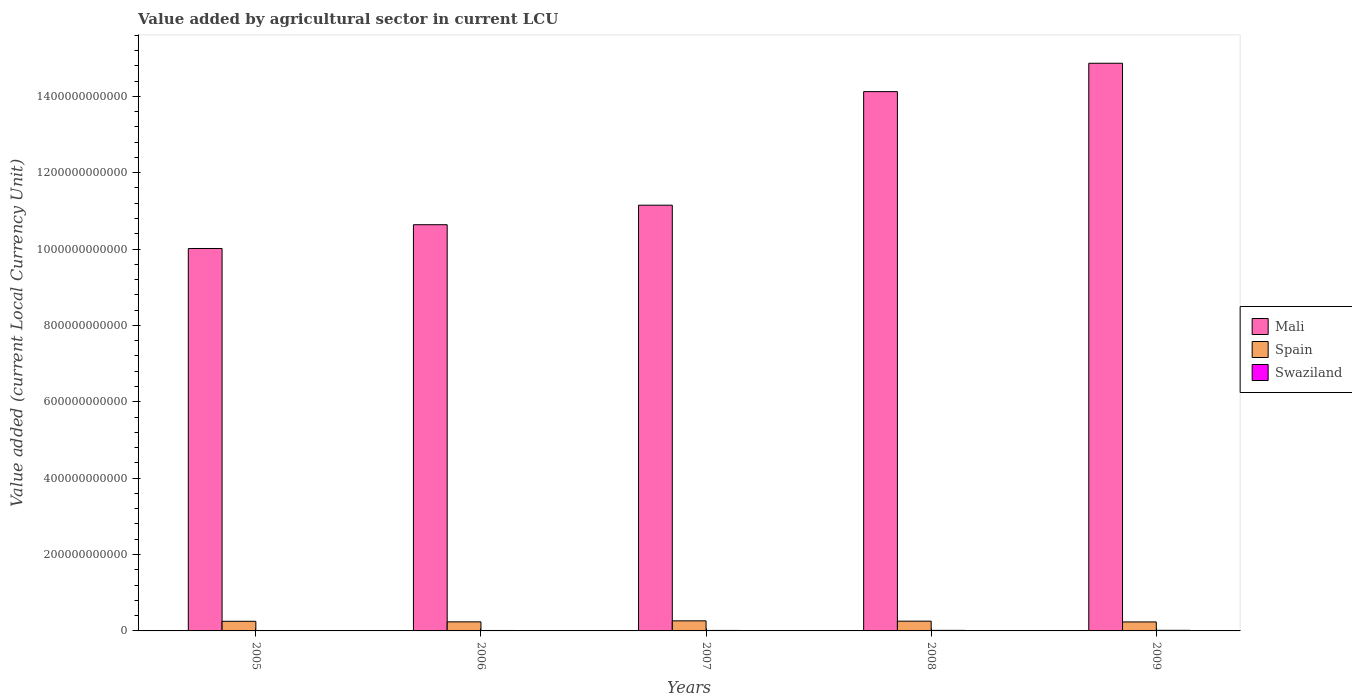Are the number of bars per tick equal to the number of legend labels?
Make the answer very short. Yes. Are the number of bars on each tick of the X-axis equal?
Give a very brief answer. Yes. What is the label of the 3rd group of bars from the left?
Your answer should be very brief. 2007. What is the value added by agricultural sector in Spain in 2006?
Your answer should be very brief. 2.37e+1. Across all years, what is the maximum value added by agricultural sector in Spain?
Your answer should be very brief. 2.64e+1. Across all years, what is the minimum value added by agricultural sector in Spain?
Give a very brief answer. 2.35e+1. In which year was the value added by agricultural sector in Swaziland maximum?
Your response must be concise. 2009. In which year was the value added by agricultural sector in Mali minimum?
Your response must be concise. 2005. What is the total value added by agricultural sector in Swaziland in the graph?
Give a very brief answer. 6.62e+09. What is the difference between the value added by agricultural sector in Swaziland in 2006 and that in 2007?
Your answer should be compact. -1.26e+08. What is the difference between the value added by agricultural sector in Swaziland in 2007 and the value added by agricultural sector in Spain in 2006?
Your answer should be very brief. -2.25e+1. What is the average value added by agricultural sector in Spain per year?
Your response must be concise. 2.49e+1. In the year 2005, what is the difference between the value added by agricultural sector in Mali and value added by agricultural sector in Swaziland?
Ensure brevity in your answer.  1.00e+12. What is the ratio of the value added by agricultural sector in Swaziland in 2006 to that in 2008?
Provide a succinct answer. 0.79. Is the difference between the value added by agricultural sector in Mali in 2005 and 2006 greater than the difference between the value added by agricultural sector in Swaziland in 2005 and 2006?
Make the answer very short. No. What is the difference between the highest and the second highest value added by agricultural sector in Swaziland?
Provide a short and direct response. 1.28e+08. What is the difference between the highest and the lowest value added by agricultural sector in Swaziland?
Ensure brevity in your answer.  4.49e+08. What does the 3rd bar from the left in 2008 represents?
Ensure brevity in your answer.  Swaziland. What does the 1st bar from the right in 2007 represents?
Your response must be concise. Swaziland. Is it the case that in every year, the sum of the value added by agricultural sector in Spain and value added by agricultural sector in Mali is greater than the value added by agricultural sector in Swaziland?
Offer a terse response. Yes. Are all the bars in the graph horizontal?
Ensure brevity in your answer.  No. How many years are there in the graph?
Your answer should be compact. 5. What is the difference between two consecutive major ticks on the Y-axis?
Your answer should be very brief. 2.00e+11. Are the values on the major ticks of Y-axis written in scientific E-notation?
Provide a succinct answer. No. Does the graph contain any zero values?
Provide a short and direct response. No. How many legend labels are there?
Offer a terse response. 3. What is the title of the graph?
Provide a succinct answer. Value added by agricultural sector in current LCU. Does "Serbia" appear as one of the legend labels in the graph?
Give a very brief answer. No. What is the label or title of the Y-axis?
Ensure brevity in your answer.  Value added (current Local Currency Unit). What is the Value added (current Local Currency Unit) in Mali in 2005?
Your answer should be very brief. 1.00e+12. What is the Value added (current Local Currency Unit) in Spain in 2005?
Offer a very short reply. 2.52e+1. What is the Value added (current Local Currency Unit) of Swaziland in 2005?
Your answer should be very brief. 1.14e+09. What is the Value added (current Local Currency Unit) of Mali in 2006?
Your answer should be very brief. 1.06e+12. What is the Value added (current Local Currency Unit) of Spain in 2006?
Offer a very short reply. 2.37e+1. What is the Value added (current Local Currency Unit) in Swaziland in 2006?
Ensure brevity in your answer.  1.15e+09. What is the Value added (current Local Currency Unit) in Mali in 2007?
Provide a short and direct response. 1.11e+12. What is the Value added (current Local Currency Unit) of Spain in 2007?
Ensure brevity in your answer.  2.64e+1. What is the Value added (current Local Currency Unit) in Swaziland in 2007?
Your answer should be very brief. 1.28e+09. What is the Value added (current Local Currency Unit) of Mali in 2008?
Give a very brief answer. 1.41e+12. What is the Value added (current Local Currency Unit) in Spain in 2008?
Offer a very short reply. 2.56e+1. What is the Value added (current Local Currency Unit) of Swaziland in 2008?
Keep it short and to the point. 1.46e+09. What is the Value added (current Local Currency Unit) of Mali in 2009?
Offer a terse response. 1.49e+12. What is the Value added (current Local Currency Unit) of Spain in 2009?
Your answer should be compact. 2.35e+1. What is the Value added (current Local Currency Unit) of Swaziland in 2009?
Make the answer very short. 1.59e+09. Across all years, what is the maximum Value added (current Local Currency Unit) in Mali?
Your answer should be compact. 1.49e+12. Across all years, what is the maximum Value added (current Local Currency Unit) of Spain?
Your answer should be very brief. 2.64e+1. Across all years, what is the maximum Value added (current Local Currency Unit) of Swaziland?
Give a very brief answer. 1.59e+09. Across all years, what is the minimum Value added (current Local Currency Unit) in Mali?
Ensure brevity in your answer.  1.00e+12. Across all years, what is the minimum Value added (current Local Currency Unit) of Spain?
Make the answer very short. 2.35e+1. Across all years, what is the minimum Value added (current Local Currency Unit) of Swaziland?
Give a very brief answer. 1.14e+09. What is the total Value added (current Local Currency Unit) in Mali in the graph?
Provide a short and direct response. 6.08e+12. What is the total Value added (current Local Currency Unit) of Spain in the graph?
Ensure brevity in your answer.  1.24e+11. What is the total Value added (current Local Currency Unit) in Swaziland in the graph?
Offer a terse response. 6.62e+09. What is the difference between the Value added (current Local Currency Unit) of Mali in 2005 and that in 2006?
Provide a succinct answer. -6.22e+1. What is the difference between the Value added (current Local Currency Unit) in Spain in 2005 and that in 2006?
Provide a succinct answer. 1.49e+09. What is the difference between the Value added (current Local Currency Unit) of Swaziland in 2005 and that in 2006?
Make the answer very short. -1.25e+07. What is the difference between the Value added (current Local Currency Unit) in Mali in 2005 and that in 2007?
Your answer should be compact. -1.13e+11. What is the difference between the Value added (current Local Currency Unit) in Spain in 2005 and that in 2007?
Provide a succinct answer. -1.14e+09. What is the difference between the Value added (current Local Currency Unit) in Swaziland in 2005 and that in 2007?
Offer a very short reply. -1.38e+08. What is the difference between the Value added (current Local Currency Unit) in Mali in 2005 and that in 2008?
Provide a succinct answer. -4.11e+11. What is the difference between the Value added (current Local Currency Unit) of Spain in 2005 and that in 2008?
Offer a very short reply. -3.23e+08. What is the difference between the Value added (current Local Currency Unit) of Swaziland in 2005 and that in 2008?
Provide a succinct answer. -3.20e+08. What is the difference between the Value added (current Local Currency Unit) of Mali in 2005 and that in 2009?
Your response must be concise. -4.85e+11. What is the difference between the Value added (current Local Currency Unit) in Spain in 2005 and that in 2009?
Give a very brief answer. 1.69e+09. What is the difference between the Value added (current Local Currency Unit) of Swaziland in 2005 and that in 2009?
Offer a terse response. -4.49e+08. What is the difference between the Value added (current Local Currency Unit) of Mali in 2006 and that in 2007?
Offer a very short reply. -5.11e+1. What is the difference between the Value added (current Local Currency Unit) in Spain in 2006 and that in 2007?
Give a very brief answer. -2.63e+09. What is the difference between the Value added (current Local Currency Unit) of Swaziland in 2006 and that in 2007?
Offer a terse response. -1.26e+08. What is the difference between the Value added (current Local Currency Unit) of Mali in 2006 and that in 2008?
Offer a very short reply. -3.49e+11. What is the difference between the Value added (current Local Currency Unit) of Spain in 2006 and that in 2008?
Offer a terse response. -1.81e+09. What is the difference between the Value added (current Local Currency Unit) in Swaziland in 2006 and that in 2008?
Your answer should be compact. -3.08e+08. What is the difference between the Value added (current Local Currency Unit) in Mali in 2006 and that in 2009?
Offer a very short reply. -4.23e+11. What is the difference between the Value added (current Local Currency Unit) in Spain in 2006 and that in 2009?
Keep it short and to the point. 1.99e+08. What is the difference between the Value added (current Local Currency Unit) of Swaziland in 2006 and that in 2009?
Provide a short and direct response. -4.36e+08. What is the difference between the Value added (current Local Currency Unit) in Mali in 2007 and that in 2008?
Your answer should be compact. -2.97e+11. What is the difference between the Value added (current Local Currency Unit) of Spain in 2007 and that in 2008?
Your response must be concise. 8.15e+08. What is the difference between the Value added (current Local Currency Unit) in Swaziland in 2007 and that in 2008?
Keep it short and to the point. -1.82e+08. What is the difference between the Value added (current Local Currency Unit) of Mali in 2007 and that in 2009?
Offer a terse response. -3.72e+11. What is the difference between the Value added (current Local Currency Unit) of Spain in 2007 and that in 2009?
Your answer should be compact. 2.83e+09. What is the difference between the Value added (current Local Currency Unit) in Swaziland in 2007 and that in 2009?
Provide a short and direct response. -3.10e+08. What is the difference between the Value added (current Local Currency Unit) in Mali in 2008 and that in 2009?
Offer a very short reply. -7.43e+1. What is the difference between the Value added (current Local Currency Unit) in Spain in 2008 and that in 2009?
Ensure brevity in your answer.  2.01e+09. What is the difference between the Value added (current Local Currency Unit) of Swaziland in 2008 and that in 2009?
Make the answer very short. -1.28e+08. What is the difference between the Value added (current Local Currency Unit) in Mali in 2005 and the Value added (current Local Currency Unit) in Spain in 2006?
Give a very brief answer. 9.78e+11. What is the difference between the Value added (current Local Currency Unit) in Mali in 2005 and the Value added (current Local Currency Unit) in Swaziland in 2006?
Your response must be concise. 1.00e+12. What is the difference between the Value added (current Local Currency Unit) of Spain in 2005 and the Value added (current Local Currency Unit) of Swaziland in 2006?
Offer a terse response. 2.41e+1. What is the difference between the Value added (current Local Currency Unit) in Mali in 2005 and the Value added (current Local Currency Unit) in Spain in 2007?
Provide a short and direct response. 9.75e+11. What is the difference between the Value added (current Local Currency Unit) of Mali in 2005 and the Value added (current Local Currency Unit) of Swaziland in 2007?
Provide a succinct answer. 1.00e+12. What is the difference between the Value added (current Local Currency Unit) in Spain in 2005 and the Value added (current Local Currency Unit) in Swaziland in 2007?
Offer a very short reply. 2.40e+1. What is the difference between the Value added (current Local Currency Unit) in Mali in 2005 and the Value added (current Local Currency Unit) in Spain in 2008?
Provide a short and direct response. 9.76e+11. What is the difference between the Value added (current Local Currency Unit) in Mali in 2005 and the Value added (current Local Currency Unit) in Swaziland in 2008?
Your answer should be very brief. 1.00e+12. What is the difference between the Value added (current Local Currency Unit) in Spain in 2005 and the Value added (current Local Currency Unit) in Swaziland in 2008?
Offer a terse response. 2.38e+1. What is the difference between the Value added (current Local Currency Unit) of Mali in 2005 and the Value added (current Local Currency Unit) of Spain in 2009?
Ensure brevity in your answer.  9.78e+11. What is the difference between the Value added (current Local Currency Unit) in Mali in 2005 and the Value added (current Local Currency Unit) in Swaziland in 2009?
Keep it short and to the point. 1.00e+12. What is the difference between the Value added (current Local Currency Unit) in Spain in 2005 and the Value added (current Local Currency Unit) in Swaziland in 2009?
Offer a terse response. 2.37e+1. What is the difference between the Value added (current Local Currency Unit) in Mali in 2006 and the Value added (current Local Currency Unit) in Spain in 2007?
Your answer should be very brief. 1.04e+12. What is the difference between the Value added (current Local Currency Unit) of Mali in 2006 and the Value added (current Local Currency Unit) of Swaziland in 2007?
Make the answer very short. 1.06e+12. What is the difference between the Value added (current Local Currency Unit) of Spain in 2006 and the Value added (current Local Currency Unit) of Swaziland in 2007?
Provide a short and direct response. 2.25e+1. What is the difference between the Value added (current Local Currency Unit) in Mali in 2006 and the Value added (current Local Currency Unit) in Spain in 2008?
Your answer should be compact. 1.04e+12. What is the difference between the Value added (current Local Currency Unit) of Mali in 2006 and the Value added (current Local Currency Unit) of Swaziland in 2008?
Your answer should be very brief. 1.06e+12. What is the difference between the Value added (current Local Currency Unit) of Spain in 2006 and the Value added (current Local Currency Unit) of Swaziland in 2008?
Offer a terse response. 2.23e+1. What is the difference between the Value added (current Local Currency Unit) of Mali in 2006 and the Value added (current Local Currency Unit) of Spain in 2009?
Offer a terse response. 1.04e+12. What is the difference between the Value added (current Local Currency Unit) of Mali in 2006 and the Value added (current Local Currency Unit) of Swaziland in 2009?
Offer a terse response. 1.06e+12. What is the difference between the Value added (current Local Currency Unit) in Spain in 2006 and the Value added (current Local Currency Unit) in Swaziland in 2009?
Your answer should be compact. 2.22e+1. What is the difference between the Value added (current Local Currency Unit) of Mali in 2007 and the Value added (current Local Currency Unit) of Spain in 2008?
Your answer should be compact. 1.09e+12. What is the difference between the Value added (current Local Currency Unit) in Mali in 2007 and the Value added (current Local Currency Unit) in Swaziland in 2008?
Your response must be concise. 1.11e+12. What is the difference between the Value added (current Local Currency Unit) of Spain in 2007 and the Value added (current Local Currency Unit) of Swaziland in 2008?
Provide a short and direct response. 2.49e+1. What is the difference between the Value added (current Local Currency Unit) of Mali in 2007 and the Value added (current Local Currency Unit) of Spain in 2009?
Provide a succinct answer. 1.09e+12. What is the difference between the Value added (current Local Currency Unit) of Mali in 2007 and the Value added (current Local Currency Unit) of Swaziland in 2009?
Your answer should be very brief. 1.11e+12. What is the difference between the Value added (current Local Currency Unit) in Spain in 2007 and the Value added (current Local Currency Unit) in Swaziland in 2009?
Provide a succinct answer. 2.48e+1. What is the difference between the Value added (current Local Currency Unit) in Mali in 2008 and the Value added (current Local Currency Unit) in Spain in 2009?
Ensure brevity in your answer.  1.39e+12. What is the difference between the Value added (current Local Currency Unit) of Mali in 2008 and the Value added (current Local Currency Unit) of Swaziland in 2009?
Your answer should be compact. 1.41e+12. What is the difference between the Value added (current Local Currency Unit) of Spain in 2008 and the Value added (current Local Currency Unit) of Swaziland in 2009?
Offer a terse response. 2.40e+1. What is the average Value added (current Local Currency Unit) in Mali per year?
Provide a short and direct response. 1.22e+12. What is the average Value added (current Local Currency Unit) in Spain per year?
Ensure brevity in your answer.  2.49e+1. What is the average Value added (current Local Currency Unit) in Swaziland per year?
Ensure brevity in your answer.  1.32e+09. In the year 2005, what is the difference between the Value added (current Local Currency Unit) in Mali and Value added (current Local Currency Unit) in Spain?
Your answer should be compact. 9.76e+11. In the year 2005, what is the difference between the Value added (current Local Currency Unit) in Mali and Value added (current Local Currency Unit) in Swaziland?
Your answer should be very brief. 1.00e+12. In the year 2005, what is the difference between the Value added (current Local Currency Unit) of Spain and Value added (current Local Currency Unit) of Swaziland?
Keep it short and to the point. 2.41e+1. In the year 2006, what is the difference between the Value added (current Local Currency Unit) in Mali and Value added (current Local Currency Unit) in Spain?
Your response must be concise. 1.04e+12. In the year 2006, what is the difference between the Value added (current Local Currency Unit) in Mali and Value added (current Local Currency Unit) in Swaziland?
Keep it short and to the point. 1.06e+12. In the year 2006, what is the difference between the Value added (current Local Currency Unit) of Spain and Value added (current Local Currency Unit) of Swaziland?
Keep it short and to the point. 2.26e+1. In the year 2007, what is the difference between the Value added (current Local Currency Unit) in Mali and Value added (current Local Currency Unit) in Spain?
Offer a very short reply. 1.09e+12. In the year 2007, what is the difference between the Value added (current Local Currency Unit) in Mali and Value added (current Local Currency Unit) in Swaziland?
Your answer should be compact. 1.11e+12. In the year 2007, what is the difference between the Value added (current Local Currency Unit) of Spain and Value added (current Local Currency Unit) of Swaziland?
Your response must be concise. 2.51e+1. In the year 2008, what is the difference between the Value added (current Local Currency Unit) in Mali and Value added (current Local Currency Unit) in Spain?
Make the answer very short. 1.39e+12. In the year 2008, what is the difference between the Value added (current Local Currency Unit) of Mali and Value added (current Local Currency Unit) of Swaziland?
Offer a terse response. 1.41e+12. In the year 2008, what is the difference between the Value added (current Local Currency Unit) in Spain and Value added (current Local Currency Unit) in Swaziland?
Provide a short and direct response. 2.41e+1. In the year 2009, what is the difference between the Value added (current Local Currency Unit) of Mali and Value added (current Local Currency Unit) of Spain?
Your response must be concise. 1.46e+12. In the year 2009, what is the difference between the Value added (current Local Currency Unit) in Mali and Value added (current Local Currency Unit) in Swaziland?
Keep it short and to the point. 1.48e+12. In the year 2009, what is the difference between the Value added (current Local Currency Unit) of Spain and Value added (current Local Currency Unit) of Swaziland?
Ensure brevity in your answer.  2.20e+1. What is the ratio of the Value added (current Local Currency Unit) of Mali in 2005 to that in 2006?
Make the answer very short. 0.94. What is the ratio of the Value added (current Local Currency Unit) in Spain in 2005 to that in 2006?
Your answer should be very brief. 1.06. What is the ratio of the Value added (current Local Currency Unit) in Swaziland in 2005 to that in 2006?
Keep it short and to the point. 0.99. What is the ratio of the Value added (current Local Currency Unit) in Mali in 2005 to that in 2007?
Your response must be concise. 0.9. What is the ratio of the Value added (current Local Currency Unit) in Spain in 2005 to that in 2007?
Your answer should be compact. 0.96. What is the ratio of the Value added (current Local Currency Unit) in Swaziland in 2005 to that in 2007?
Offer a very short reply. 0.89. What is the ratio of the Value added (current Local Currency Unit) of Mali in 2005 to that in 2008?
Keep it short and to the point. 0.71. What is the ratio of the Value added (current Local Currency Unit) in Spain in 2005 to that in 2008?
Give a very brief answer. 0.99. What is the ratio of the Value added (current Local Currency Unit) in Swaziland in 2005 to that in 2008?
Offer a very short reply. 0.78. What is the ratio of the Value added (current Local Currency Unit) in Mali in 2005 to that in 2009?
Give a very brief answer. 0.67. What is the ratio of the Value added (current Local Currency Unit) of Spain in 2005 to that in 2009?
Offer a terse response. 1.07. What is the ratio of the Value added (current Local Currency Unit) of Swaziland in 2005 to that in 2009?
Provide a short and direct response. 0.72. What is the ratio of the Value added (current Local Currency Unit) in Mali in 2006 to that in 2007?
Offer a terse response. 0.95. What is the ratio of the Value added (current Local Currency Unit) of Spain in 2006 to that in 2007?
Provide a succinct answer. 0.9. What is the ratio of the Value added (current Local Currency Unit) in Swaziland in 2006 to that in 2007?
Keep it short and to the point. 0.9. What is the ratio of the Value added (current Local Currency Unit) of Mali in 2006 to that in 2008?
Make the answer very short. 0.75. What is the ratio of the Value added (current Local Currency Unit) in Spain in 2006 to that in 2008?
Your answer should be very brief. 0.93. What is the ratio of the Value added (current Local Currency Unit) in Swaziland in 2006 to that in 2008?
Ensure brevity in your answer.  0.79. What is the ratio of the Value added (current Local Currency Unit) in Mali in 2006 to that in 2009?
Provide a succinct answer. 0.72. What is the ratio of the Value added (current Local Currency Unit) of Spain in 2006 to that in 2009?
Give a very brief answer. 1.01. What is the ratio of the Value added (current Local Currency Unit) of Swaziland in 2006 to that in 2009?
Provide a succinct answer. 0.73. What is the ratio of the Value added (current Local Currency Unit) in Mali in 2007 to that in 2008?
Ensure brevity in your answer.  0.79. What is the ratio of the Value added (current Local Currency Unit) in Spain in 2007 to that in 2008?
Your answer should be compact. 1.03. What is the ratio of the Value added (current Local Currency Unit) in Swaziland in 2007 to that in 2008?
Ensure brevity in your answer.  0.88. What is the ratio of the Value added (current Local Currency Unit) of Spain in 2007 to that in 2009?
Ensure brevity in your answer.  1.12. What is the ratio of the Value added (current Local Currency Unit) in Swaziland in 2007 to that in 2009?
Provide a succinct answer. 0.8. What is the ratio of the Value added (current Local Currency Unit) in Mali in 2008 to that in 2009?
Keep it short and to the point. 0.95. What is the ratio of the Value added (current Local Currency Unit) of Spain in 2008 to that in 2009?
Your answer should be compact. 1.09. What is the ratio of the Value added (current Local Currency Unit) of Swaziland in 2008 to that in 2009?
Keep it short and to the point. 0.92. What is the difference between the highest and the second highest Value added (current Local Currency Unit) of Mali?
Give a very brief answer. 7.43e+1. What is the difference between the highest and the second highest Value added (current Local Currency Unit) of Spain?
Provide a succinct answer. 8.15e+08. What is the difference between the highest and the second highest Value added (current Local Currency Unit) of Swaziland?
Offer a terse response. 1.28e+08. What is the difference between the highest and the lowest Value added (current Local Currency Unit) of Mali?
Provide a succinct answer. 4.85e+11. What is the difference between the highest and the lowest Value added (current Local Currency Unit) in Spain?
Provide a short and direct response. 2.83e+09. What is the difference between the highest and the lowest Value added (current Local Currency Unit) in Swaziland?
Ensure brevity in your answer.  4.49e+08. 